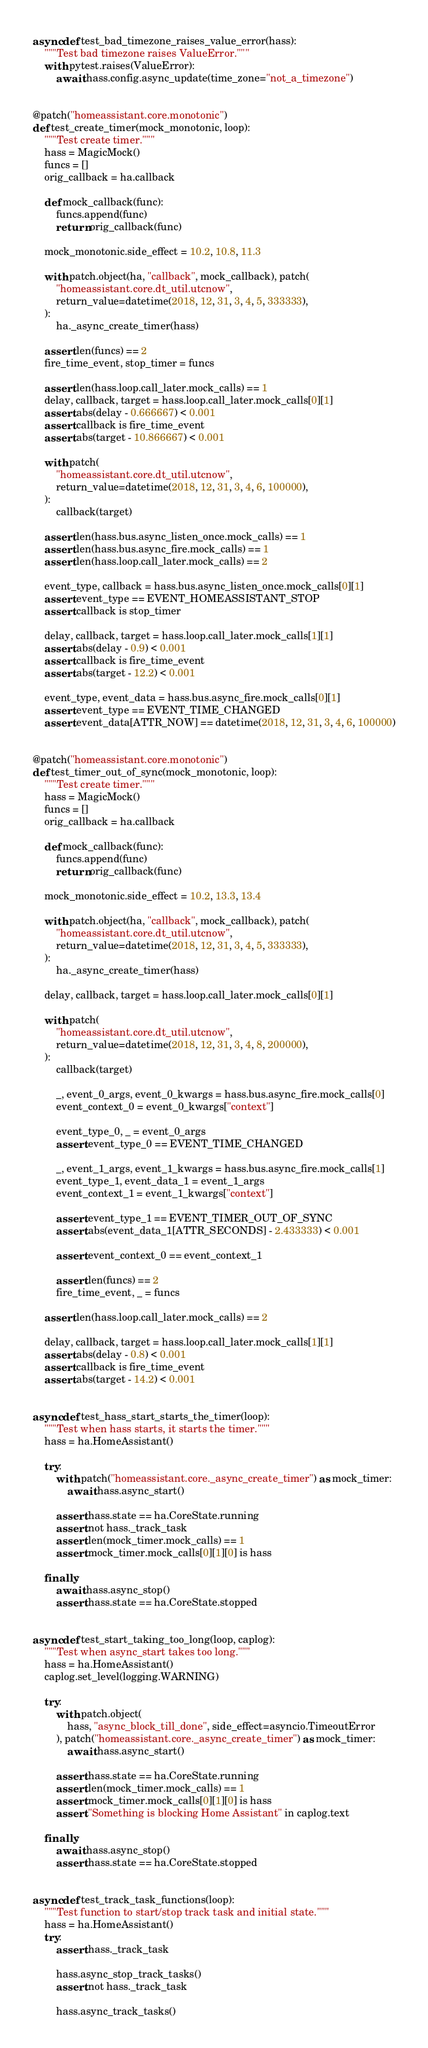Convert code to text. <code><loc_0><loc_0><loc_500><loc_500><_Python_>
async def test_bad_timezone_raises_value_error(hass):
    """Test bad timezone raises ValueError."""
    with pytest.raises(ValueError):
        await hass.config.async_update(time_zone="not_a_timezone")


@patch("homeassistant.core.monotonic")
def test_create_timer(mock_monotonic, loop):
    """Test create timer."""
    hass = MagicMock()
    funcs = []
    orig_callback = ha.callback

    def mock_callback(func):
        funcs.append(func)
        return orig_callback(func)

    mock_monotonic.side_effect = 10.2, 10.8, 11.3

    with patch.object(ha, "callback", mock_callback), patch(
        "homeassistant.core.dt_util.utcnow",
        return_value=datetime(2018, 12, 31, 3, 4, 5, 333333),
    ):
        ha._async_create_timer(hass)

    assert len(funcs) == 2
    fire_time_event, stop_timer = funcs

    assert len(hass.loop.call_later.mock_calls) == 1
    delay, callback, target = hass.loop.call_later.mock_calls[0][1]
    assert abs(delay - 0.666667) < 0.001
    assert callback is fire_time_event
    assert abs(target - 10.866667) < 0.001

    with patch(
        "homeassistant.core.dt_util.utcnow",
        return_value=datetime(2018, 12, 31, 3, 4, 6, 100000),
    ):
        callback(target)

    assert len(hass.bus.async_listen_once.mock_calls) == 1
    assert len(hass.bus.async_fire.mock_calls) == 1
    assert len(hass.loop.call_later.mock_calls) == 2

    event_type, callback = hass.bus.async_listen_once.mock_calls[0][1]
    assert event_type == EVENT_HOMEASSISTANT_STOP
    assert callback is stop_timer

    delay, callback, target = hass.loop.call_later.mock_calls[1][1]
    assert abs(delay - 0.9) < 0.001
    assert callback is fire_time_event
    assert abs(target - 12.2) < 0.001

    event_type, event_data = hass.bus.async_fire.mock_calls[0][1]
    assert event_type == EVENT_TIME_CHANGED
    assert event_data[ATTR_NOW] == datetime(2018, 12, 31, 3, 4, 6, 100000)


@patch("homeassistant.core.monotonic")
def test_timer_out_of_sync(mock_monotonic, loop):
    """Test create timer."""
    hass = MagicMock()
    funcs = []
    orig_callback = ha.callback

    def mock_callback(func):
        funcs.append(func)
        return orig_callback(func)

    mock_monotonic.side_effect = 10.2, 13.3, 13.4

    with patch.object(ha, "callback", mock_callback), patch(
        "homeassistant.core.dt_util.utcnow",
        return_value=datetime(2018, 12, 31, 3, 4, 5, 333333),
    ):
        ha._async_create_timer(hass)

    delay, callback, target = hass.loop.call_later.mock_calls[0][1]

    with patch(
        "homeassistant.core.dt_util.utcnow",
        return_value=datetime(2018, 12, 31, 3, 4, 8, 200000),
    ):
        callback(target)

        _, event_0_args, event_0_kwargs = hass.bus.async_fire.mock_calls[0]
        event_context_0 = event_0_kwargs["context"]

        event_type_0, _ = event_0_args
        assert event_type_0 == EVENT_TIME_CHANGED

        _, event_1_args, event_1_kwargs = hass.bus.async_fire.mock_calls[1]
        event_type_1, event_data_1 = event_1_args
        event_context_1 = event_1_kwargs["context"]

        assert event_type_1 == EVENT_TIMER_OUT_OF_SYNC
        assert abs(event_data_1[ATTR_SECONDS] - 2.433333) < 0.001

        assert event_context_0 == event_context_1

        assert len(funcs) == 2
        fire_time_event, _ = funcs

    assert len(hass.loop.call_later.mock_calls) == 2

    delay, callback, target = hass.loop.call_later.mock_calls[1][1]
    assert abs(delay - 0.8) < 0.001
    assert callback is fire_time_event
    assert abs(target - 14.2) < 0.001


async def test_hass_start_starts_the_timer(loop):
    """Test when hass starts, it starts the timer."""
    hass = ha.HomeAssistant()

    try:
        with patch("homeassistant.core._async_create_timer") as mock_timer:
            await hass.async_start()

        assert hass.state == ha.CoreState.running
        assert not hass._track_task
        assert len(mock_timer.mock_calls) == 1
        assert mock_timer.mock_calls[0][1][0] is hass

    finally:
        await hass.async_stop()
        assert hass.state == ha.CoreState.stopped


async def test_start_taking_too_long(loop, caplog):
    """Test when async_start takes too long."""
    hass = ha.HomeAssistant()
    caplog.set_level(logging.WARNING)

    try:
        with patch.object(
            hass, "async_block_till_done", side_effect=asyncio.TimeoutError
        ), patch("homeassistant.core._async_create_timer") as mock_timer:
            await hass.async_start()

        assert hass.state == ha.CoreState.running
        assert len(mock_timer.mock_calls) == 1
        assert mock_timer.mock_calls[0][1][0] is hass
        assert "Something is blocking Home Assistant" in caplog.text

    finally:
        await hass.async_stop()
        assert hass.state == ha.CoreState.stopped


async def test_track_task_functions(loop):
    """Test function to start/stop track task and initial state."""
    hass = ha.HomeAssistant()
    try:
        assert hass._track_task

        hass.async_stop_track_tasks()
        assert not hass._track_task

        hass.async_track_tasks()</code> 